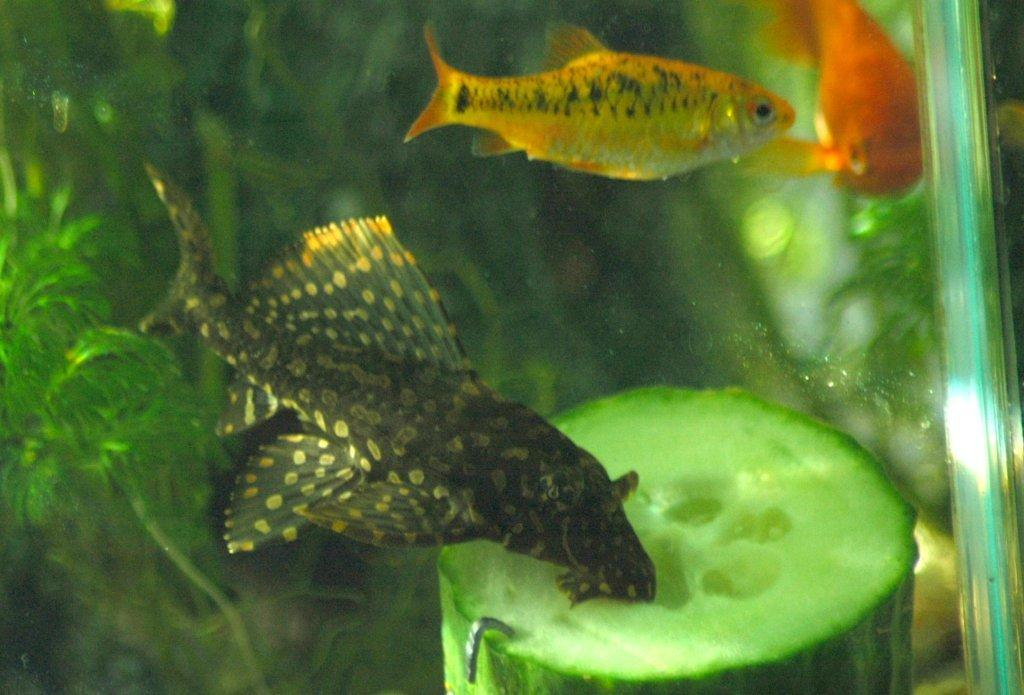What type of animals can be seen in the foreground of the image? There are fish in the water in the foreground of the image. What is located at the bottom of the water in the image? There is a vegetable at the bottom of the water in the image. What type of plant is present in the background of the image? There is an artificial plant in the background of the image. What type of punishment is being administered to the fish in the image? There is no punishment being administered to the fish in the image; they are simply swimming in the water. What time does the watch in the image show? There is no watch present in the image. 